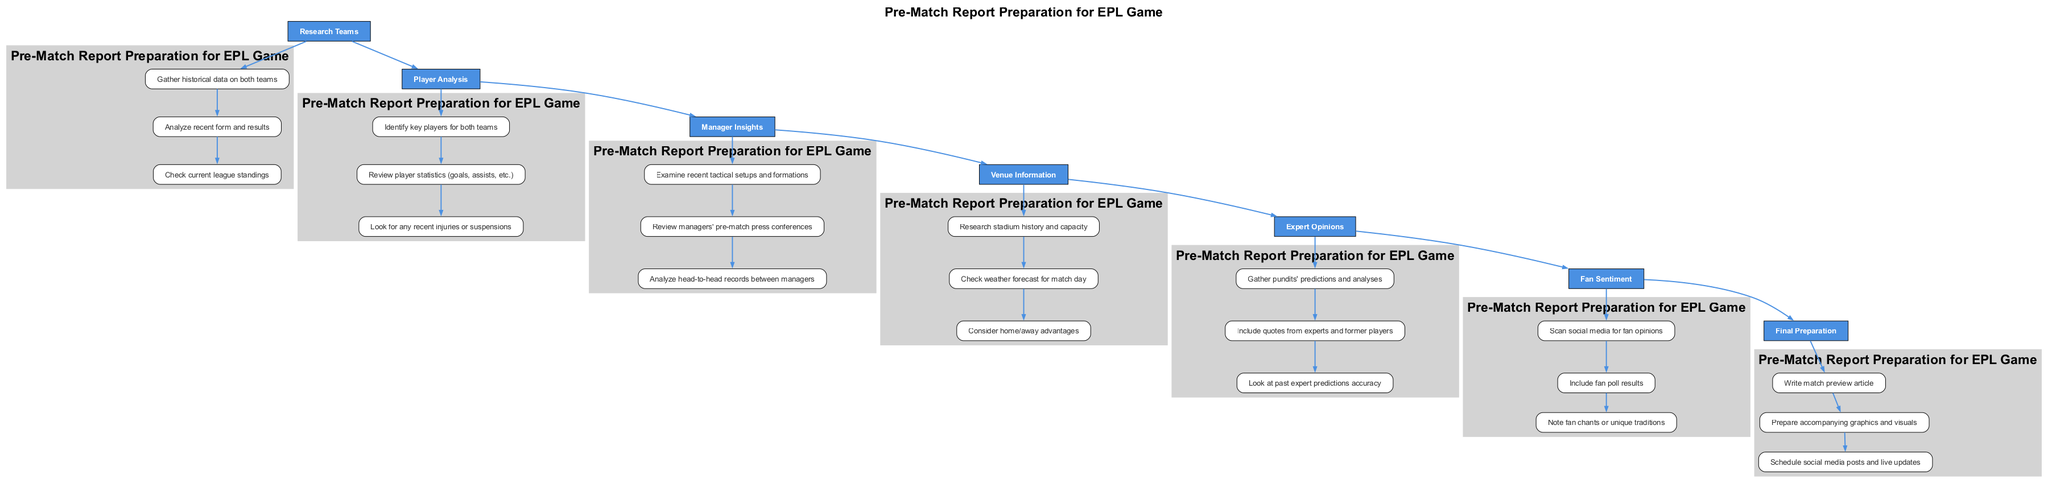What is the first step in preparing a pre-match report? The first step listed in the diagram is "Research Teams." This information can be found at the top of the flowchart, indicating the initial action to take.
Answer: Research Teams How many detailed items are listed under "Player Analysis"? There are three detailed items under the "Player Analysis" step. To find this, I counted the entries specifically listed beneath the "Player Analysis" node in the diagram.
Answer: 3 Which step follows "Venue Information"? The step that follows "Venue Information" is "Expert Opinions." This can be determined by the downward flow of the diagram showing the sequence of steps from one to another.
Answer: Expert Opinions How many main steps are included in the pre-match report preparation? There are seven main steps in total, which can be identified by counting each individual step node present in the main flow of the diagram.
Answer: 7 What is one detail under "Manager Insights"? One detail listed under "Manager Insights" is "Examine recent tactical setups and formations." This can be found by looking at the details provided directly under that specific step in the diagram.
Answer: Examine recent tactical setups and formations What is the step directly preceding "Final Preparation"? The step directly preceding "Final Preparation" is "Fan Sentiment." This relationship can be identified by the flow connecting these two steps in the diagram.
Answer: Fan Sentiment Which section discusses the current league standings? The current league standings are discussed in the "Research Teams" section. This is evident by tracing the details listed under the corresponding main step.
Answer: Research Teams How many details mention 'injuries' or 'suspensions'? There is one detailed item that mentions injuries or suspensions, specifically under "Player Analysis." This can be confirmed by reviewing the details listed beneath "Player Analysis."
Answer: 1 